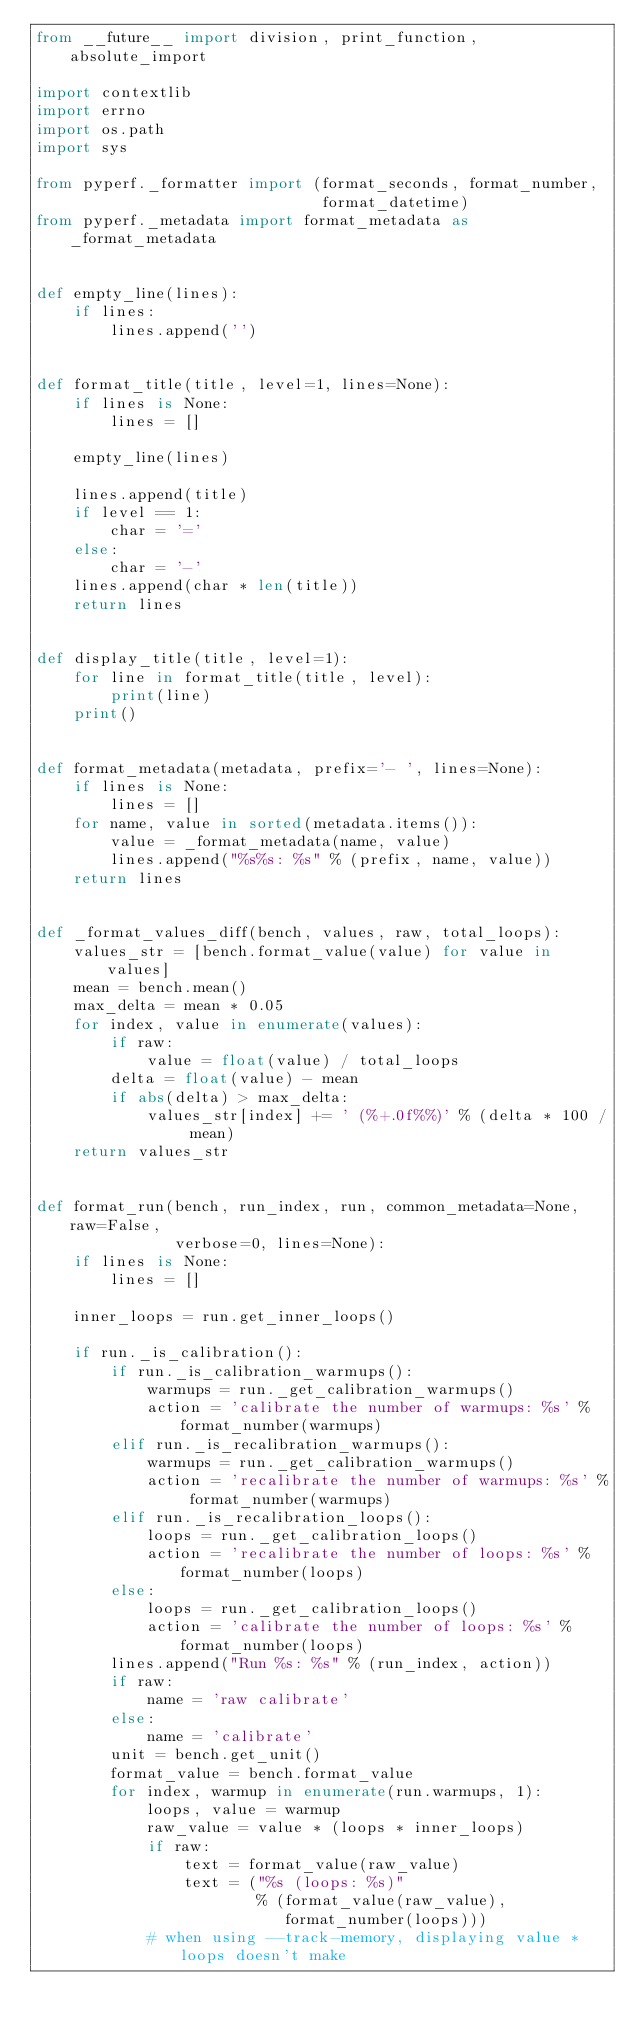Convert code to text. <code><loc_0><loc_0><loc_500><loc_500><_Python_>from __future__ import division, print_function, absolute_import

import contextlib
import errno
import os.path
import sys

from pyperf._formatter import (format_seconds, format_number,
                               format_datetime)
from pyperf._metadata import format_metadata as _format_metadata


def empty_line(lines):
    if lines:
        lines.append('')


def format_title(title, level=1, lines=None):
    if lines is None:
        lines = []

    empty_line(lines)

    lines.append(title)
    if level == 1:
        char = '='
    else:
        char = '-'
    lines.append(char * len(title))
    return lines


def display_title(title, level=1):
    for line in format_title(title, level):
        print(line)
    print()


def format_metadata(metadata, prefix='- ', lines=None):
    if lines is None:
        lines = []
    for name, value in sorted(metadata.items()):
        value = _format_metadata(name, value)
        lines.append("%s%s: %s" % (prefix, name, value))
    return lines


def _format_values_diff(bench, values, raw, total_loops):
    values_str = [bench.format_value(value) for value in values]
    mean = bench.mean()
    max_delta = mean * 0.05
    for index, value in enumerate(values):
        if raw:
            value = float(value) / total_loops
        delta = float(value) - mean
        if abs(delta) > max_delta:
            values_str[index] += ' (%+.0f%%)' % (delta * 100 / mean)
    return values_str


def format_run(bench, run_index, run, common_metadata=None, raw=False,
               verbose=0, lines=None):
    if lines is None:
        lines = []

    inner_loops = run.get_inner_loops()

    if run._is_calibration():
        if run._is_calibration_warmups():
            warmups = run._get_calibration_warmups()
            action = 'calibrate the number of warmups: %s' % format_number(warmups)
        elif run._is_recalibration_warmups():
            warmups = run._get_calibration_warmups()
            action = 'recalibrate the number of warmups: %s' % format_number(warmups)
        elif run._is_recalibration_loops():
            loops = run._get_calibration_loops()
            action = 'recalibrate the number of loops: %s' % format_number(loops)
        else:
            loops = run._get_calibration_loops()
            action = 'calibrate the number of loops: %s' % format_number(loops)
        lines.append("Run %s: %s" % (run_index, action))
        if raw:
            name = 'raw calibrate'
        else:
            name = 'calibrate'
        unit = bench.get_unit()
        format_value = bench.format_value
        for index, warmup in enumerate(run.warmups, 1):
            loops, value = warmup
            raw_value = value * (loops * inner_loops)
            if raw:
                text = format_value(raw_value)
                text = ("%s (loops: %s)"
                        % (format_value(raw_value),
                           format_number(loops)))
            # when using --track-memory, displaying value * loops doesn't make</code> 